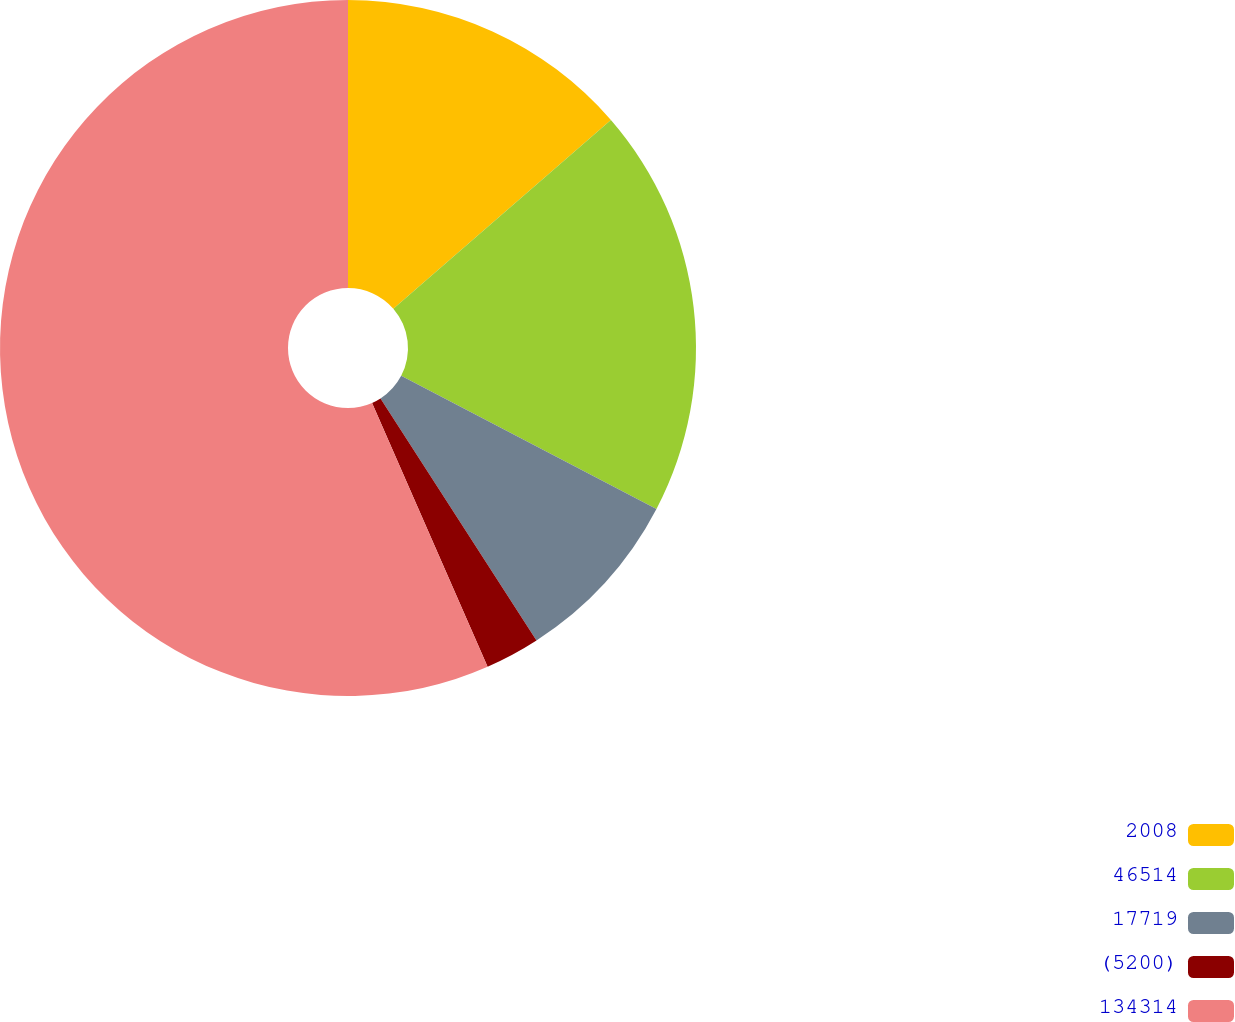Convert chart. <chart><loc_0><loc_0><loc_500><loc_500><pie_chart><fcel>2008<fcel>46514<fcel>17719<fcel>(5200)<fcel>134314<nl><fcel>13.63%<fcel>19.03%<fcel>8.23%<fcel>2.54%<fcel>56.57%<nl></chart> 